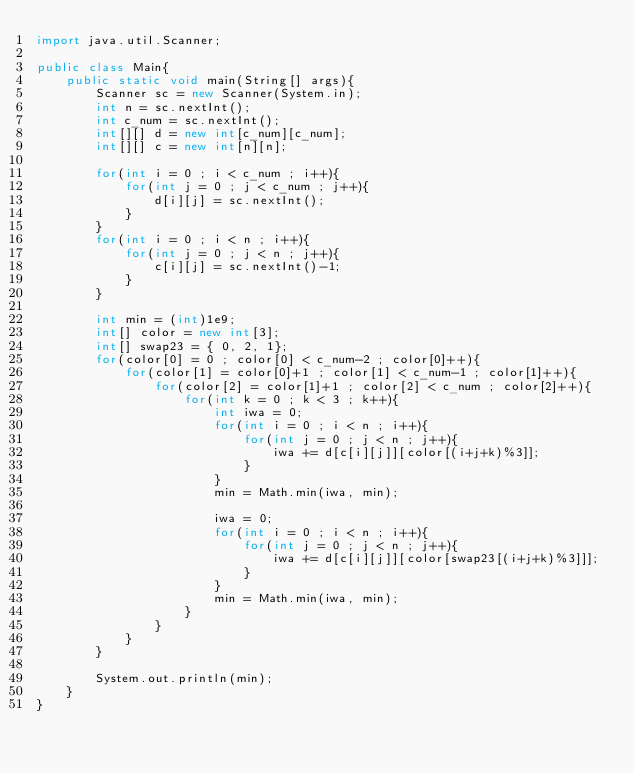<code> <loc_0><loc_0><loc_500><loc_500><_Java_>import java.util.Scanner;
 
public class Main{
	public static void main(String[] args){
    	Scanner sc = new Scanner(System.in);
      	int n = sc.nextInt();
      	int c_num = sc.nextInt();
      	int[][] d = new int[c_num][c_num];
      	int[][] c = new int[n][n];

      	for(int i = 0 ; i < c_num ; i++){
      		for(int j = 0 ; j < c_num ; j++){
      			d[i][j] = sc.nextInt();
      		}
      	}
      	for(int i = 0 ; i < n ; i++){
      		for(int j = 0 ; j < n ; j++){
      			c[i][j] = sc.nextInt()-1;
      		}
      	}

      	int min = (int)1e9;
      	int[] color = new int[3];
      	int[] swap23 = { 0, 2, 1};
      	for(color[0] = 0 ; color[0] < c_num-2 ; color[0]++){
      		for(color[1] = color[0]+1 ; color[1] < c_num-1 ; color[1]++){
      			for(color[2] = color[1]+1 ; color[2] < c_num ; color[2]++){
      				for(int k = 0 ; k < 3 ; k++){
      					int iwa = 0;
	      				for(int i = 0 ; i < n ; i++){
	      					for(int j = 0 ; j < n ; j++){
	      						iwa += d[c[i][j]][color[(i+j+k)%3]];
	      					}
	      				}
      					min = Math.min(iwa, min);

      					iwa = 0;
	      				for(int i = 0 ; i < n ; i++){
	      					for(int j = 0 ; j < n ; j++){
	      						iwa += d[c[i][j]][color[swap23[(i+j+k)%3]]];
	      					}
	      				}
      					min = Math.min(iwa, min);
      				}
      			}
      		}
      	}

      	System.out.println(min);
    }
}</code> 